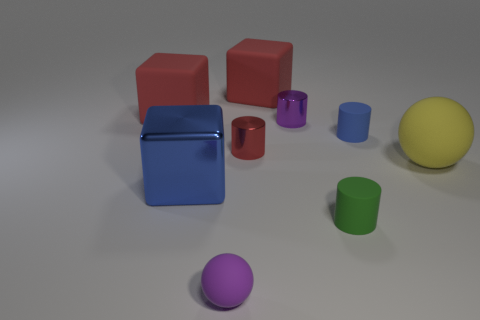Subtract all blue cylinders. How many red cubes are left? 2 Subtract all tiny green cylinders. How many cylinders are left? 3 Subtract 1 blocks. How many blocks are left? 2 Subtract all blue cylinders. How many cylinders are left? 3 Add 1 green objects. How many objects exist? 10 Subtract all gray cylinders. Subtract all blue balls. How many cylinders are left? 4 Subtract all balls. How many objects are left? 7 Add 8 blue matte things. How many blue matte things are left? 9 Add 8 small green rubber things. How many small green rubber things exist? 9 Subtract 1 green cylinders. How many objects are left? 8 